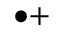Convert formula to latex. <formula><loc_0><loc_0><loc_500><loc_500>^ { \bullet + }</formula> 